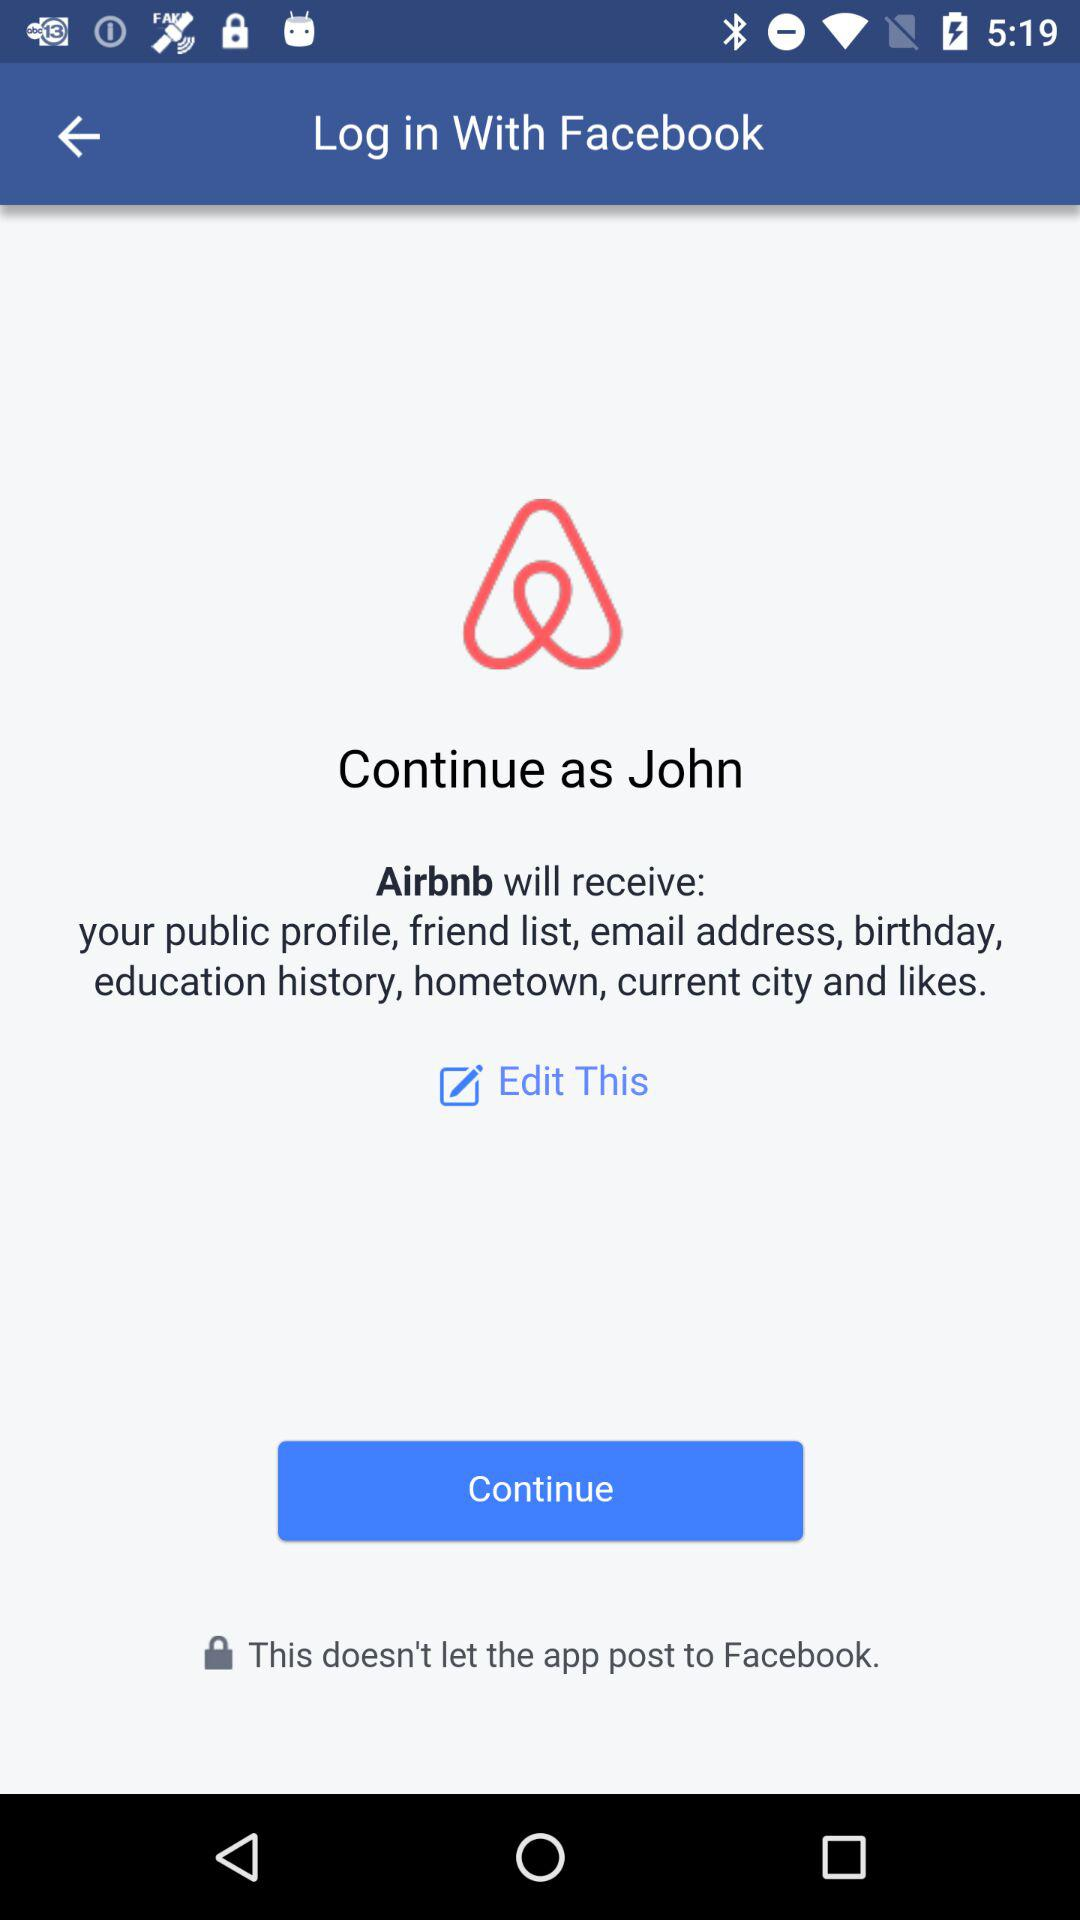What's the application name that will receive the public profile and friend list? The application name is "Airbnb". 